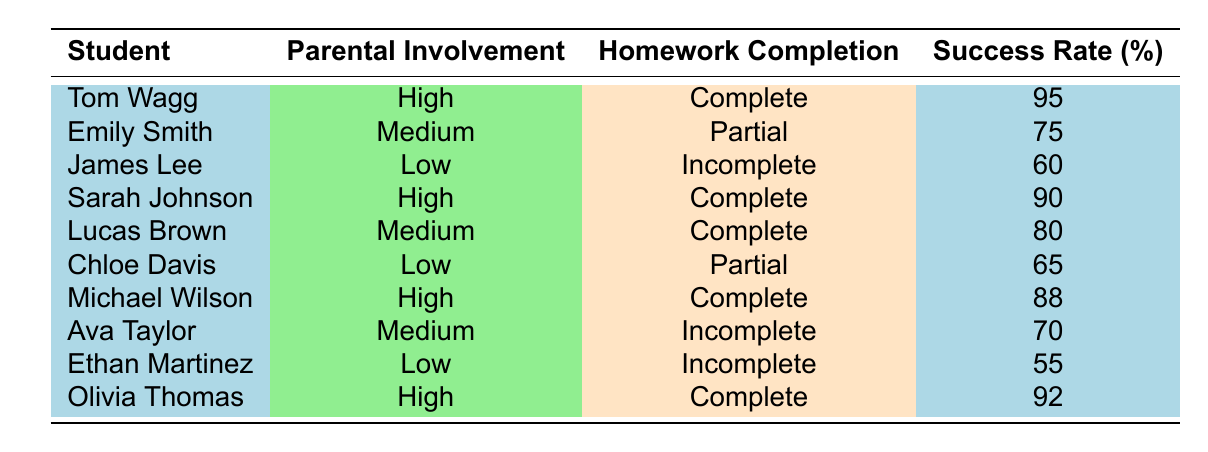What is the success rate of Tom Wagg? From the table, we find Tom Wagg listed as having a success rate of 95.
Answer: 95 How many students have a high level of parental involvement? Scanning through the table, I find three students with a high level of parental involvement: Tom Wagg, Sarah Johnson, and Michael Wilson.
Answer: 3 What is the average success rate of students with medium parental involvement? The success rates for students with medium parental involvement are 75 (Emily Smith), 80 (Lucas Brown), and 70 (Ava Taylor). To find the average, we sum these rates: 75 + 80 + 70 = 225. Since there are 3 students, the average is 225/3 = 75.
Answer: 75 Is it true that all students with high parental involvement completed their homework? Checking the table, all students listed with high parental involvement (Tom Wagg, Sarah Johnson, Michael Wilson) have "Complete" under Homework Completion, confirming the statement is true.
Answer: Yes Which student with low parental involvement had the highest success rate? Among the students with low parental involvement, James Lee has a success rate of 60, Chloe Davis has 65, and Ethan Martinez has 55. Thus, Chloe Davis with a success rate of 65 had the highest success rate.
Answer: Chloe Davis What is the success rate difference between students with high and low parental involvement? First, we need to identify success rates: High parental involvement rates are 95 (Tom Wagg), 90 (Sarah Johnson), 88 (Michael Wilson). The average for high is (95 + 90 + 88) / 3 = 91. The low scores are 60 (James Lee), 65 (Chloe Davis), 55 (Ethan Martinez), leading to an average of (60 + 65 + 55) / 3 = 60. Therefore, the difference is 91 - 60 = 31.
Answer: 31 How many students completed their homework? Looking through the table, I find that the students who completed their homework are: Tom Wagg, Sarah Johnson, Michael Wilson, and Lucas Brown. So, there are four students who completed their homework.
Answer: 4 What is the median student success rate for all students? Listing all the success rates: 95, 75, 60, 90, 80, 65, 88, 70, 55, 92, we order them: 55, 60, 65, 70, 75, 80, 88, 90, 92, 95. The median is the average of the 5th and 6th values in this ordered set: (75 + 80) / 2 = 77.5.
Answer: 77.5 How many students scored below 70? Checking the success rates, Ethan Martinez (55), Chloe Davis (65), and Ava Taylor (70) scored below 70. In total, there are three students with scores below 70.
Answer: 3 